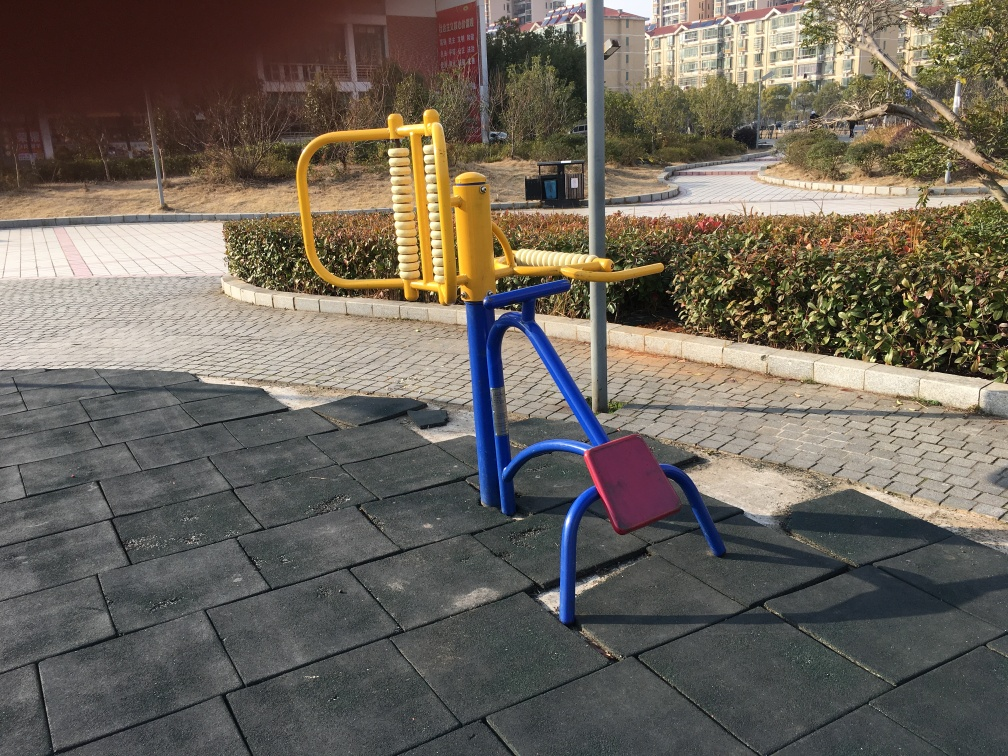What time of day does it seem to be in the image? Considering the length and position of the shadows cast by the equipment, it looks to be either in the morning or the late afternoon, when the sun is at a lower angle in the sky. What does the shadow tell us in terms of direction? The direction of the shadows suggests that the sun is either to the east or the west, depending on whether it's morning or afternoon. This can provide us with a rough idea of the cardinal directions present in the scene. 